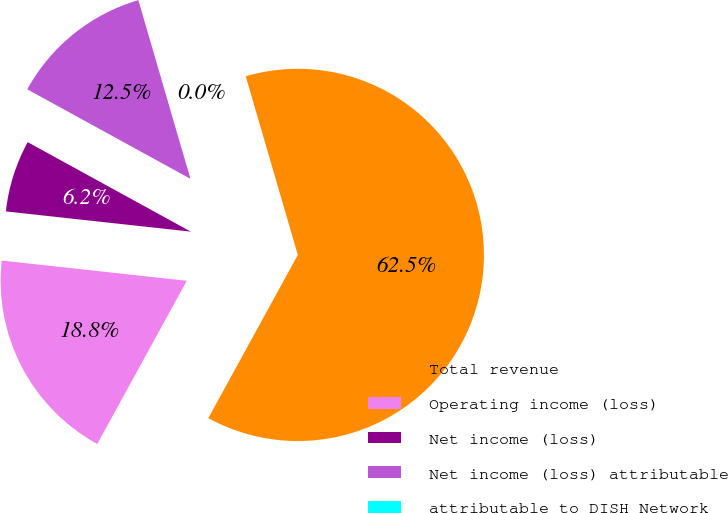Convert chart. <chart><loc_0><loc_0><loc_500><loc_500><pie_chart><fcel>Total revenue<fcel>Operating income (loss)<fcel>Net income (loss)<fcel>Net income (loss) attributable<fcel>attributable to DISH Network<nl><fcel>62.5%<fcel>18.75%<fcel>6.25%<fcel>12.5%<fcel>0.0%<nl></chart> 